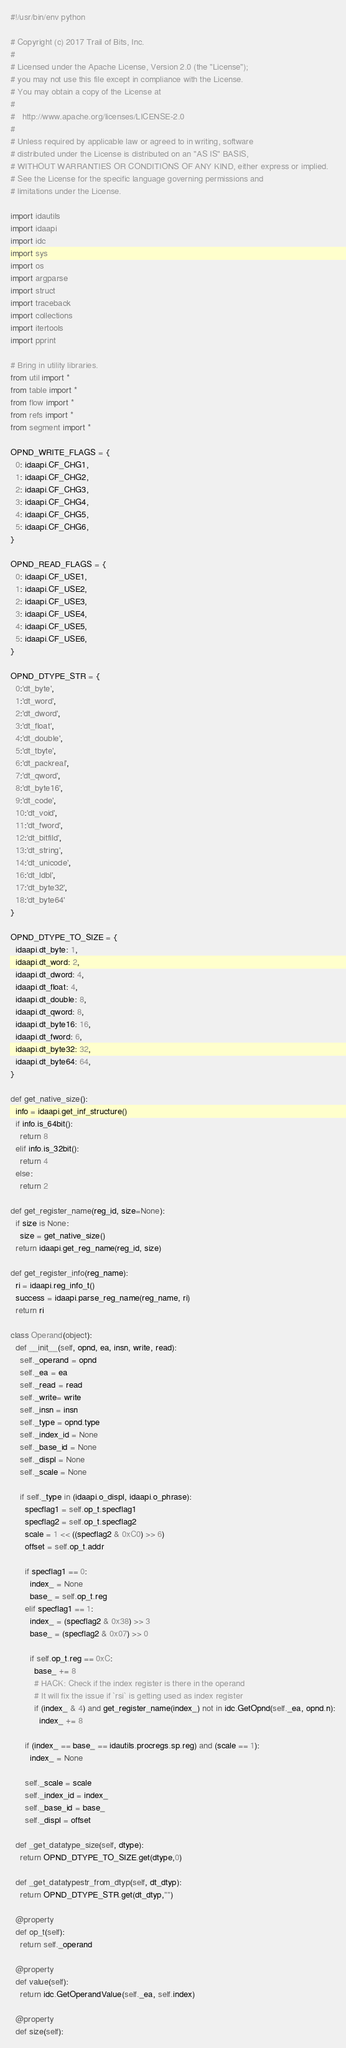Convert code to text. <code><loc_0><loc_0><loc_500><loc_500><_Python_>#!/usr/bin/env python

# Copyright (c) 2017 Trail of Bits, Inc.
#
# Licensed under the Apache License, Version 2.0 (the "License");
# you may not use this file except in compliance with the License.
# You may obtain a copy of the License at
#
#   http://www.apache.org/licenses/LICENSE-2.0
#
# Unless required by applicable law or agreed to in writing, software
# distributed under the License is distributed on an "AS IS" BASIS,
# WITHOUT WARRANTIES OR CONDITIONS OF ANY KIND, either express or implied.
# See the License for the specific language governing permissions and
# limitations under the License.

import idautils
import idaapi
import idc
import sys
import os
import argparse
import struct
import traceback
import collections
import itertools
import pprint

# Bring in utility libraries.
from util import *
from table import *
from flow import *
from refs import *
from segment import *

OPND_WRITE_FLAGS = {
  0: idaapi.CF_CHG1,
  1: idaapi.CF_CHG2,
  2: idaapi.CF_CHG3,
  3: idaapi.CF_CHG4,
  4: idaapi.CF_CHG5,
  5: idaapi.CF_CHG6,
}

OPND_READ_FLAGS = {
  0: idaapi.CF_USE1,
  1: idaapi.CF_USE2,
  2: idaapi.CF_USE3,
  3: idaapi.CF_USE4,
  4: idaapi.CF_USE5,
  5: idaapi.CF_USE6,
}

OPND_DTYPE_STR = {
  0:'dt_byte',
  1:'dt_word',
  2:'dt_dword',
  3:'dt_float',
  4:'dt_double',
  5:'dt_tbyte',
  6:'dt_packreal',
  7:'dt_qword',
  8:'dt_byte16',
  9:'dt_code',
  10:'dt_void',
  11:'dt_fword',
  12:'dt_bitfild',
  13:'dt_string',
  14:'dt_unicode',
  16:'dt_ldbl',
  17:'dt_byte32',
  18:'dt_byte64'
}

OPND_DTYPE_TO_SIZE = {
  idaapi.dt_byte: 1,
  idaapi.dt_word: 2,
  idaapi.dt_dword: 4,
  idaapi.dt_float: 4,
  idaapi.dt_double: 8,
  idaapi.dt_qword: 8,
  idaapi.dt_byte16: 16,
  idaapi.dt_fword: 6,
  idaapi.dt_byte32: 32,
  idaapi.dt_byte64: 64,
}

def get_native_size():
  info = idaapi.get_inf_structure()
  if info.is_64bit():
    return 8
  elif info.is_32bit():
    return 4
  else:
    return 2
    
def get_register_name(reg_id, size=None):
  if size is None:
    size = get_native_size()
  return idaapi.get_reg_name(reg_id, size)

def get_register_info(reg_name):
  ri = idaapi.reg_info_t()
  success = idaapi.parse_reg_name(reg_name, ri)
  return ri

class Operand(object):
  def __init__(self, opnd, ea, insn, write, read):
    self._operand = opnd
    self._ea = ea
    self._read = read
    self._write= write
    self._insn = insn
    self._type = opnd.type
    self._index_id = None
    self._base_id = None
    self._displ = None
    self._scale = None

    if self._type in (idaapi.o_displ, idaapi.o_phrase):
      specflag1 = self.op_t.specflag1
      specflag2 = self.op_t.specflag2
      scale = 1 << ((specflag2 & 0xC0) >> 6)
      offset = self.op_t.addr

      if specflag1 == 0:
        index_ = None
        base_ = self.op_t.reg
      elif specflag1 == 1:
        index_ = (specflag2 & 0x38) >> 3
        base_ = (specflag2 & 0x07) >> 0

        if self.op_t.reg == 0xC:
          base_ += 8
          # HACK: Check if the index register is there in the operand
          # It will fix the issue if `rsi` is getting used as index register
          if (index_ & 4) and get_register_name(index_) not in idc.GetOpnd(self._ea, opnd.n):
            index_ += 8

      if (index_ == base_ == idautils.procregs.sp.reg) and (scale == 1):
        index_ = None

      self._scale = scale
      self._index_id = index_
      self._base_id = base_
      self._displ = offset
               
  def _get_datatype_size(self, dtype):
    return OPND_DTYPE_TO_SIZE.get(dtype,0)
            
  def _get_datatypestr_from_dtyp(self, dt_dtyp):
    return OPND_DTYPE_STR.get(dt_dtyp,"")
    
  @property
  def op_t(self):
    return self._operand
    
  @property
  def value(self):
    return idc.GetOperandValue(self._ea, self.index)
    
  @property
  def size(self):</code> 